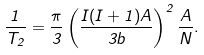Convert formula to latex. <formula><loc_0><loc_0><loc_500><loc_500>\frac { 1 } { T _ { 2 } } = \frac { \pi } { 3 } \left ( \frac { I ( I + 1 ) A } { 3 b } \right ) ^ { 2 } \frac { A } { N } .</formula> 